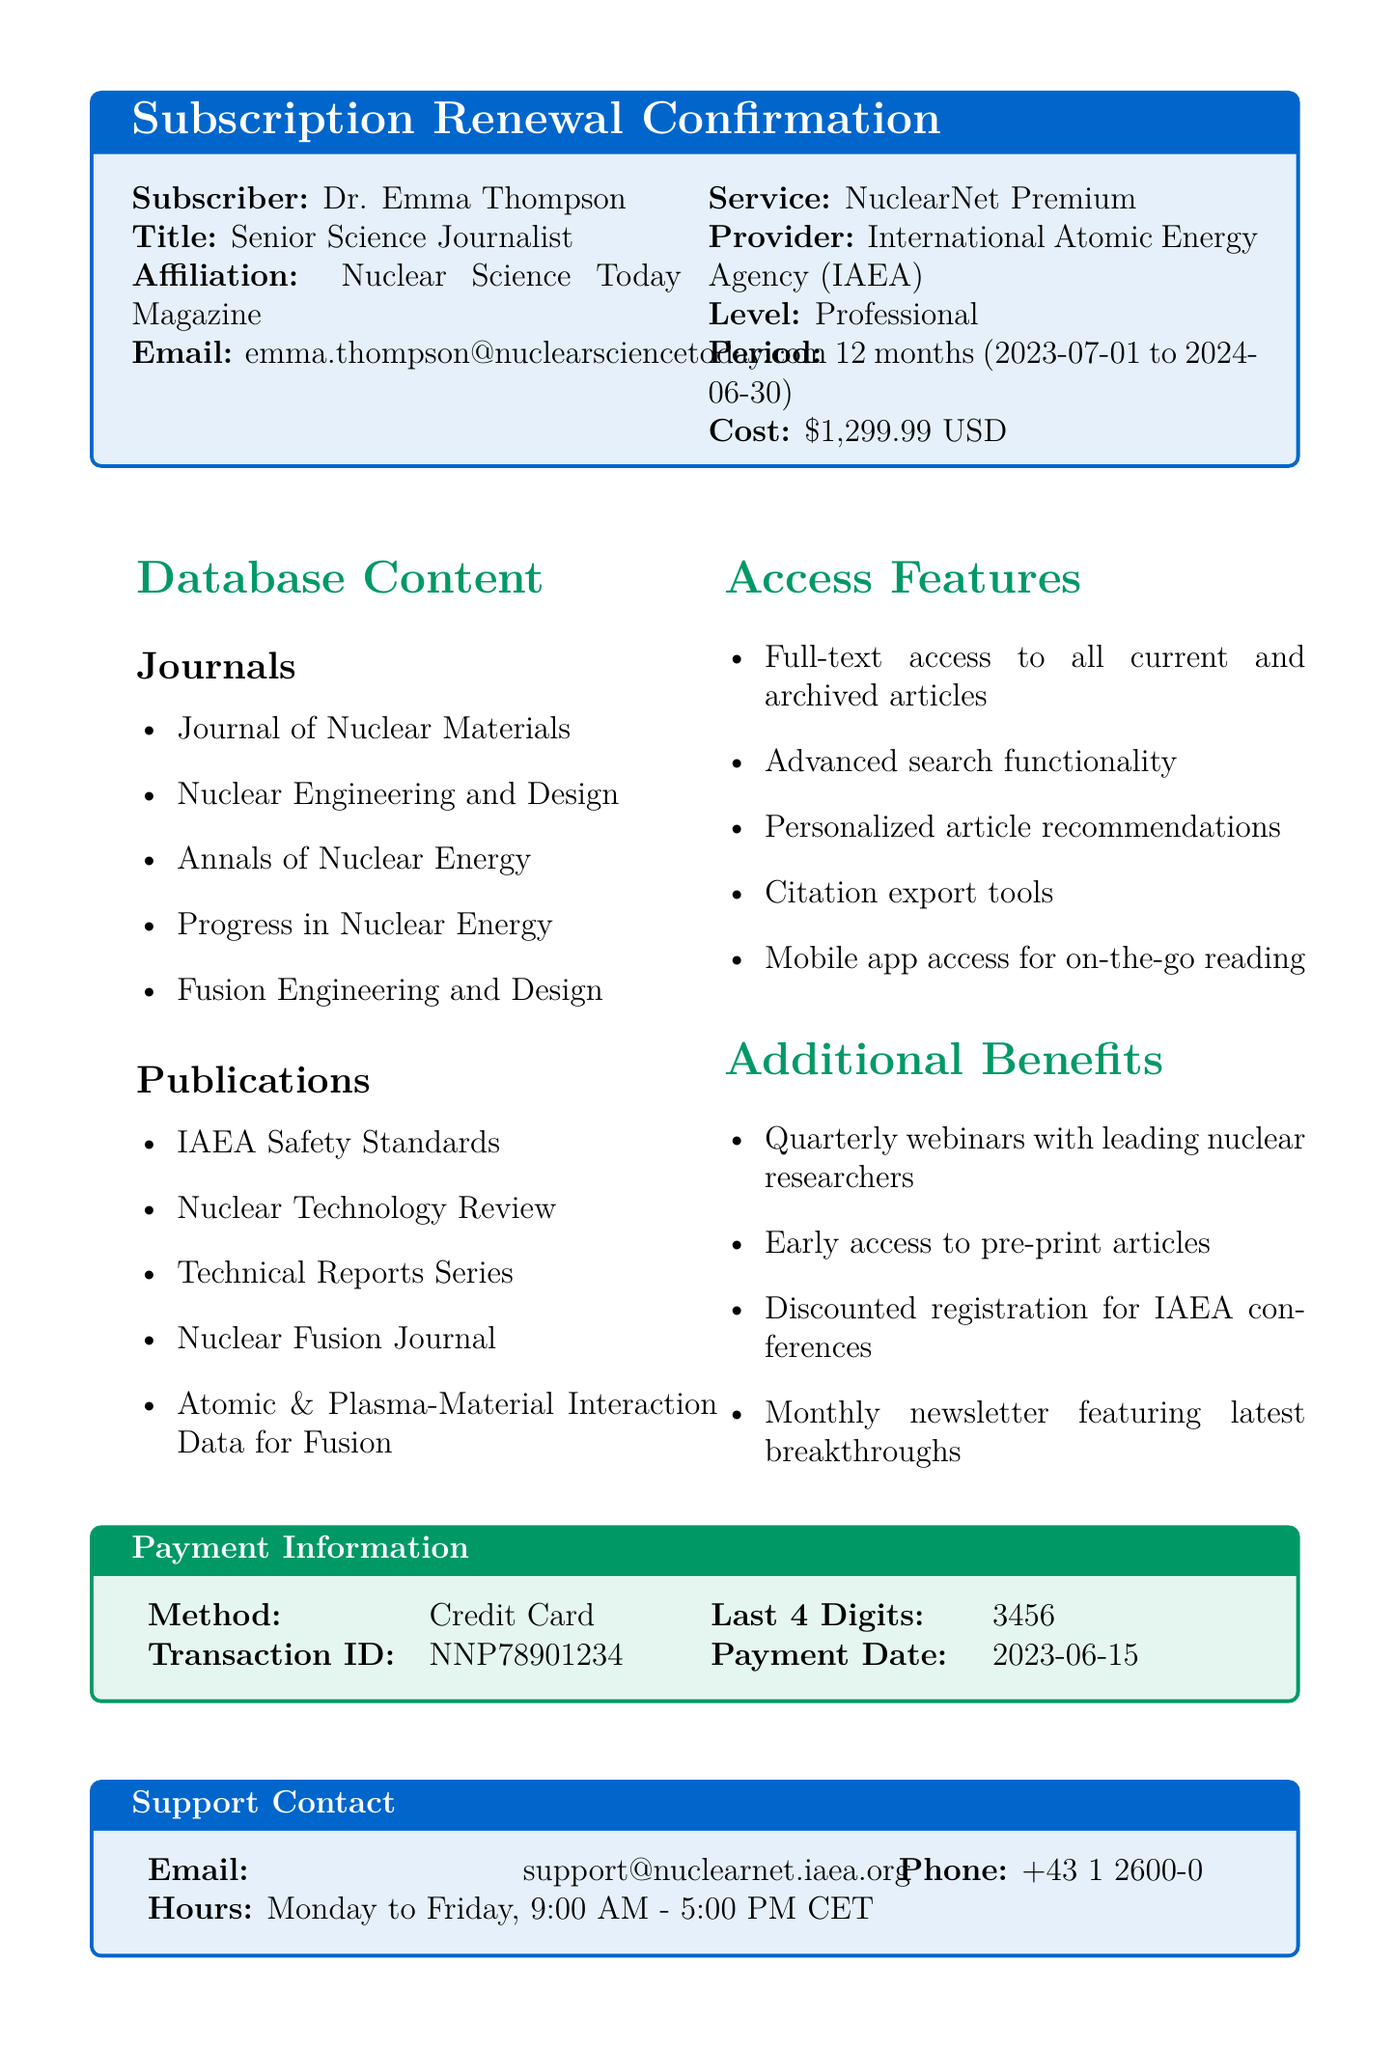What is the name of the subscriber? The name of the subscriber is specifically mentioned in the document as Dr. Emma Thompson.
Answer: Dr. Emma Thompson What is the subscription level for NuclearNet Premium? The subscription level is classified as Professional, which is explicitly stated in the document.
Answer: Professional When does the subscription period end? The end date of the subscription period is clearly indicated as June 30, 2024.
Answer: 2024-06-30 What is the cost of the subscription? The document provides the subscription cost as $1,299.99 USD.
Answer: $1,299.99 USD What additional benefit includes webinars? The document mentions quarterly webinars with leading nuclear researchers as one of the additional benefits.
Answer: Quarterly webinars What payment method was used for the subscription? The payment method used for the subscription is given as Credit Card in the payment information section.
Answer: Credit Card How long before cancellation must notice be given? The document states that a 30-day notice is required for cancellation.
Answer: 30-day What is one of the access features listed? Full-text access to all current and archived articles is mentioned as an access feature.
Answer: Full-text access Who is the provider of NuclearNet Premium? The provider is specified as the International Atomic Energy Agency (IAEA).
Answer: International Atomic Energy Agency (IAEA) 